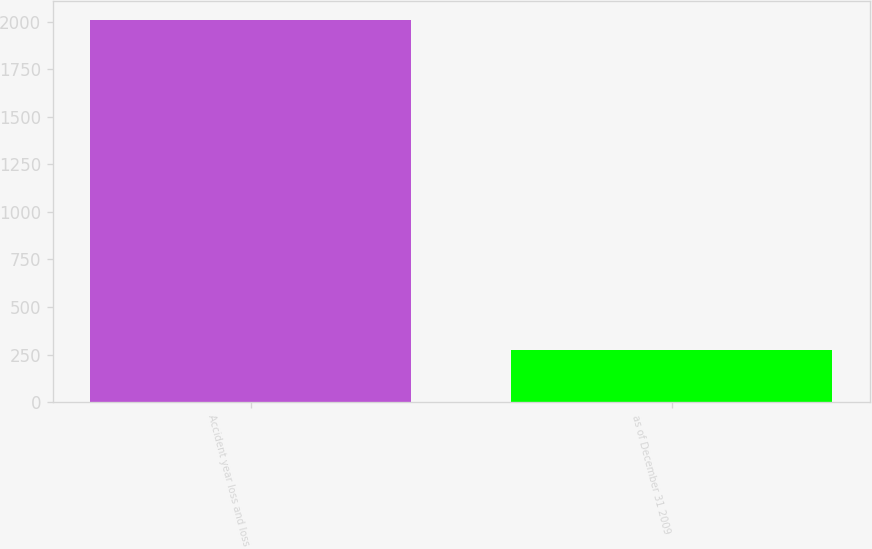Convert chart. <chart><loc_0><loc_0><loc_500><loc_500><bar_chart><fcel>Accident year loss and loss<fcel>as of December 31 2009<nl><fcel>2009<fcel>276<nl></chart> 